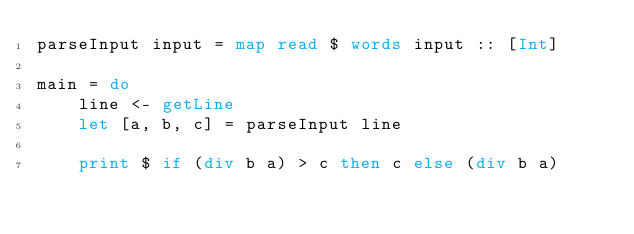<code> <loc_0><loc_0><loc_500><loc_500><_Haskell_>parseInput input = map read $ words input :: [Int]

main = do
    line <- getLine
    let [a, b, c] = parseInput line

    print $ if (div b a) > c then c else (div b a)
</code> 